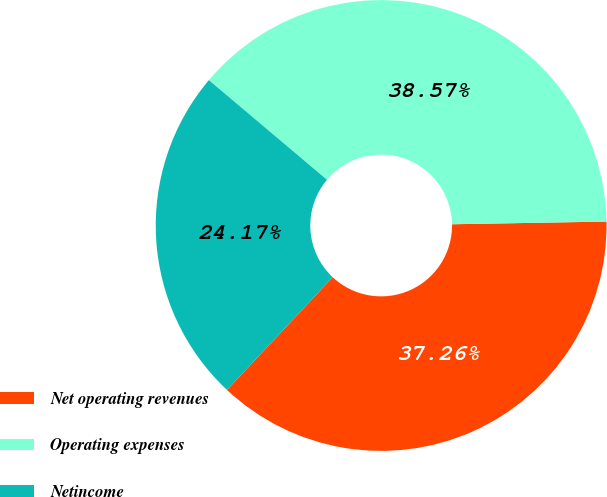<chart> <loc_0><loc_0><loc_500><loc_500><pie_chart><fcel>Net operating revenues<fcel>Operating expenses<fcel>Netincome<nl><fcel>37.26%<fcel>38.57%<fcel>24.17%<nl></chart> 